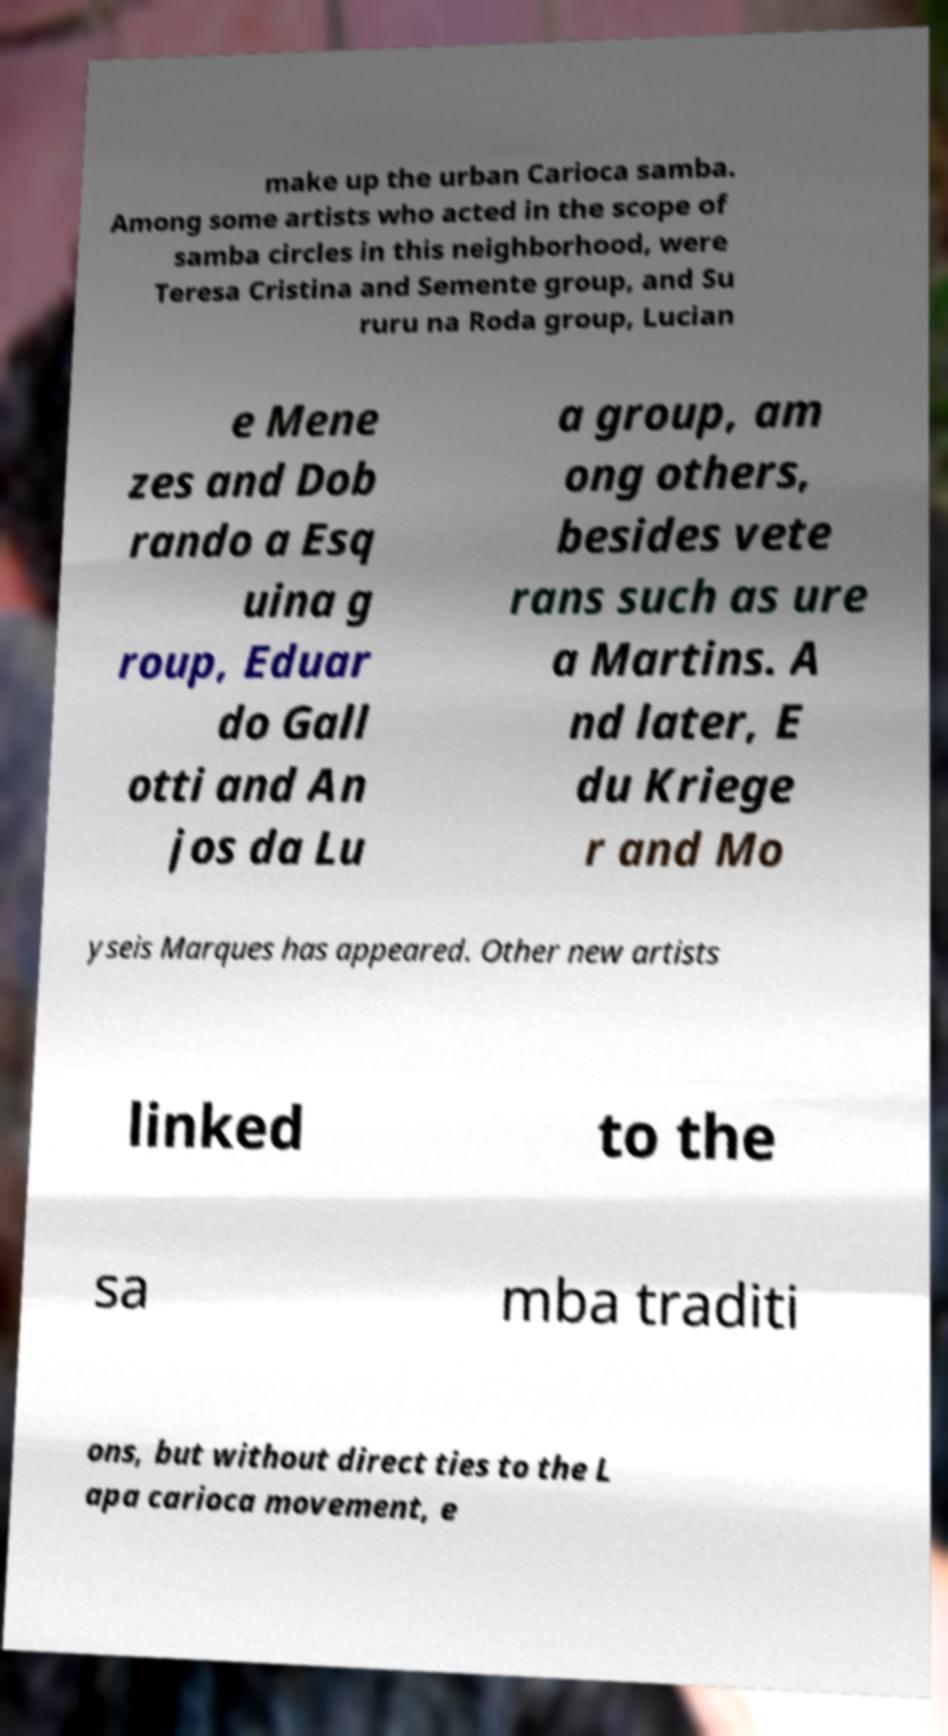There's text embedded in this image that I need extracted. Can you transcribe it verbatim? make up the urban Carioca samba. Among some artists who acted in the scope of samba circles in this neighborhood, were Teresa Cristina and Semente group, and Su ruru na Roda group, Lucian e Mene zes and Dob rando a Esq uina g roup, Eduar do Gall otti and An jos da Lu a group, am ong others, besides vete rans such as ure a Martins. A nd later, E du Kriege r and Mo yseis Marques has appeared. Other new artists linked to the sa mba traditi ons, but without direct ties to the L apa carioca movement, e 